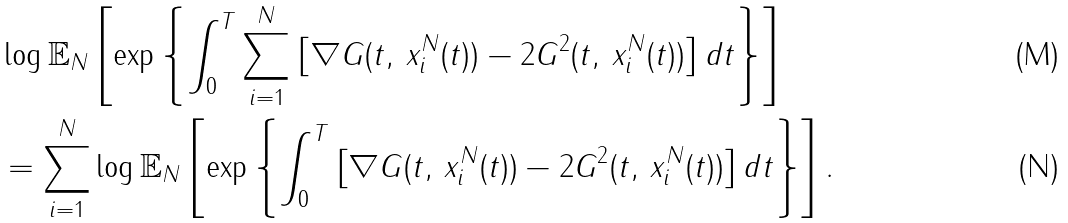Convert formula to latex. <formula><loc_0><loc_0><loc_500><loc_500>& \log \mathbb { E } _ { N } \left [ \exp \left \{ \int _ { 0 } ^ { T } \sum _ { i = 1 } ^ { N } \left [ \nabla G ( t , \, x _ { i } ^ { N } ( t ) ) - 2 G ^ { 2 } ( t , \, x _ { i } ^ { N } ( t ) ) \right ] d t \right \} \right ] \\ & = \sum _ { i = 1 } ^ { N } \log \mathbb { E } _ { N } \left [ \exp \left \{ \int _ { 0 } ^ { T } \left [ \nabla G ( t , \, x _ { i } ^ { N } ( t ) ) - 2 G ^ { 2 } ( t , \, x _ { i } ^ { N } ( t ) ) \right ] d t \right \} \right ] .</formula> 